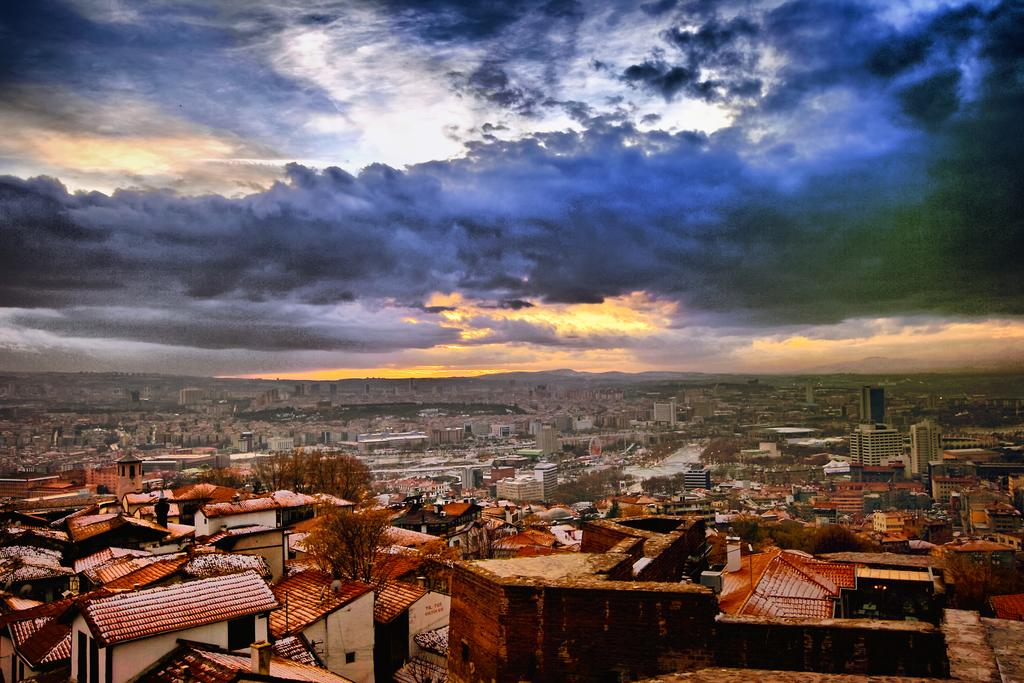What types of structures are present in the image? There are many buildings and houses in the image. What else can be seen in the image besides structures? There are trees in the image. What part of the buildings is visible in the image? Roofs are visible in the image. How would you describe the sky in the background of the image? The sky in the background is cloudy. Where is the desk located in the image? There is no desk present in the image. Can you see the mom in the image? There is no mom present in the image. 